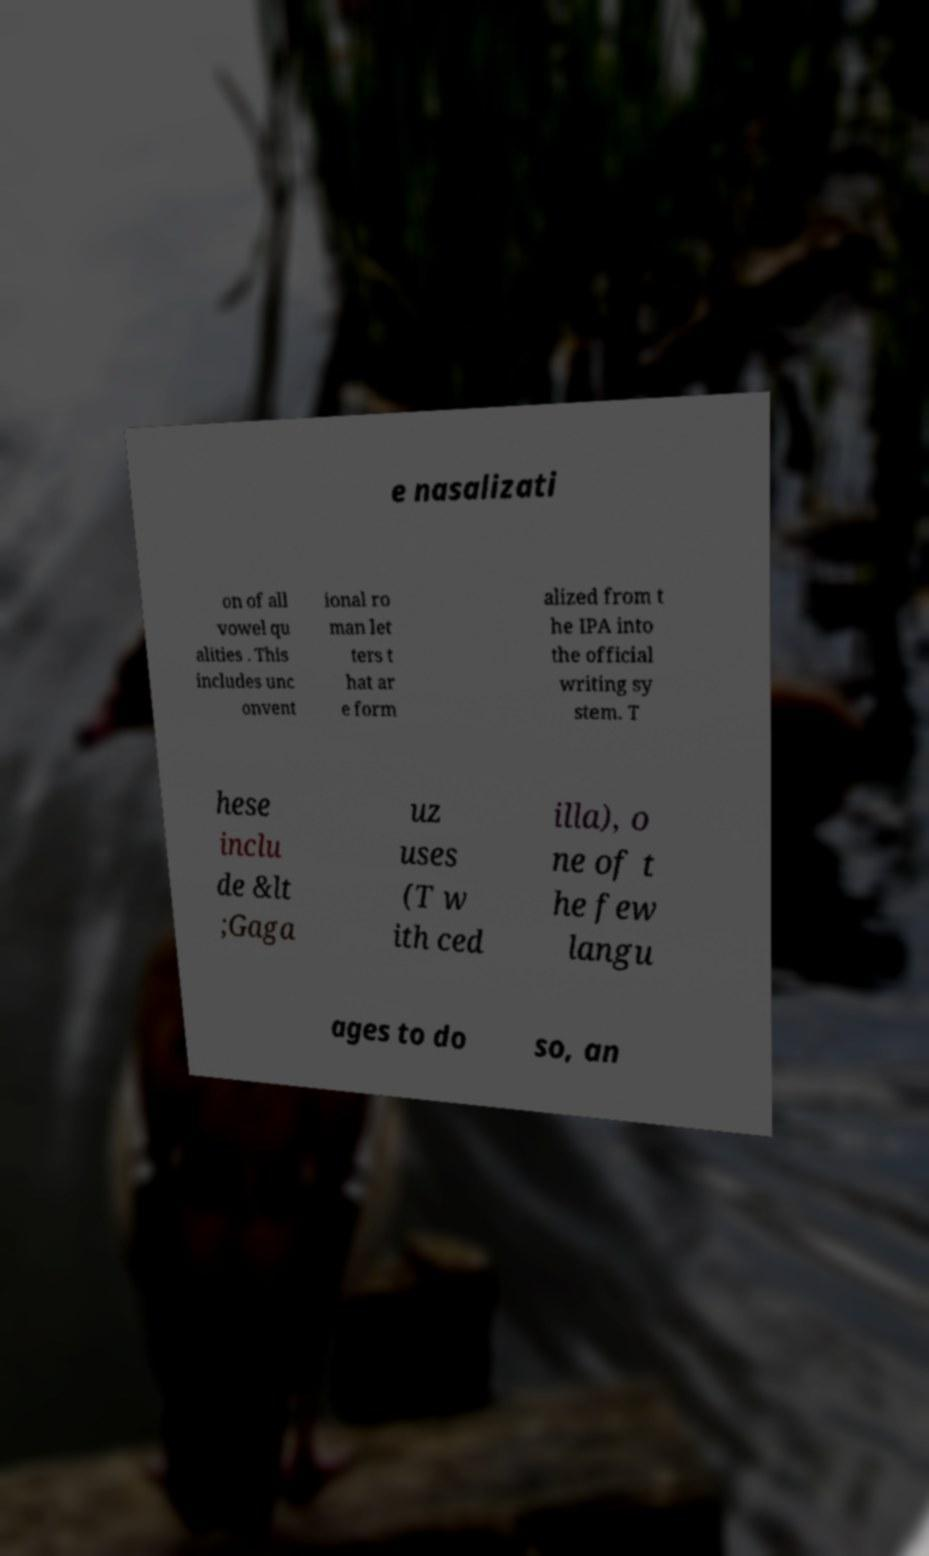Can you read and provide the text displayed in the image?This photo seems to have some interesting text. Can you extract and type it out for me? e nasalizati on of all vowel qu alities . This includes unc onvent ional ro man let ters t hat ar e form alized from t he IPA into the official writing sy stem. T hese inclu de &lt ;Gaga uz uses (T w ith ced illa), o ne of t he few langu ages to do so, an 